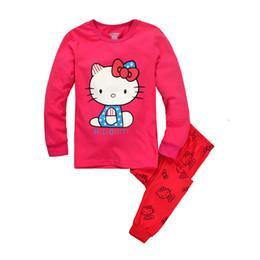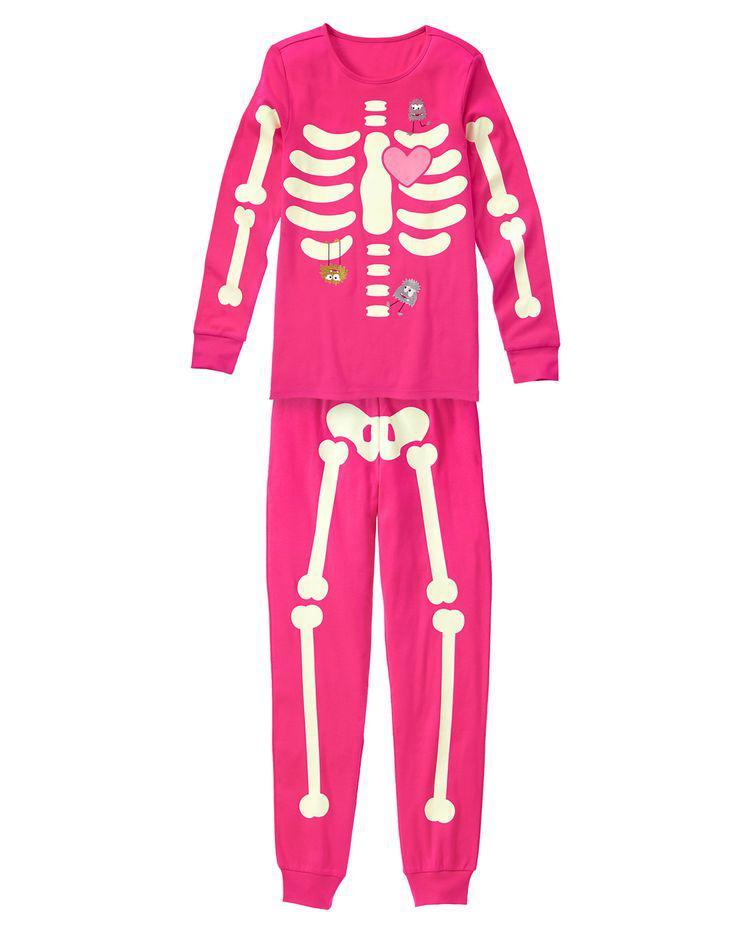The first image is the image on the left, the second image is the image on the right. Considering the images on both sides, is "At least one image shows red onesie pajamas" valid? Answer yes or no. No. The first image is the image on the left, the second image is the image on the right. Evaluate the accuracy of this statement regarding the images: "One or more outfits are """"Thing 1 and Thing 2"""" themed.". Is it true? Answer yes or no. No. 